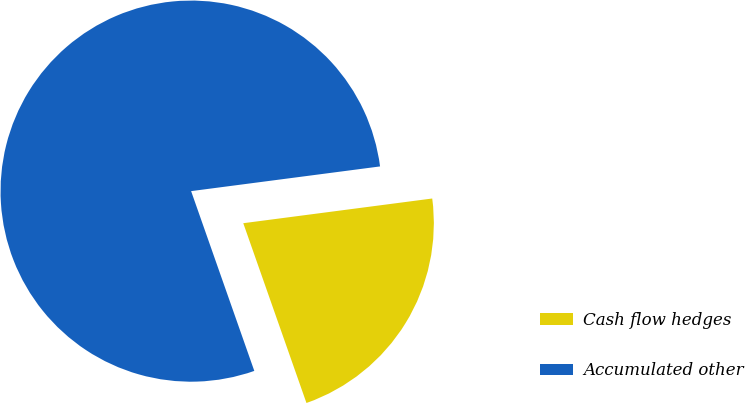Convert chart. <chart><loc_0><loc_0><loc_500><loc_500><pie_chart><fcel>Cash flow hedges<fcel>Accumulated other<nl><fcel>21.69%<fcel>78.31%<nl></chart> 